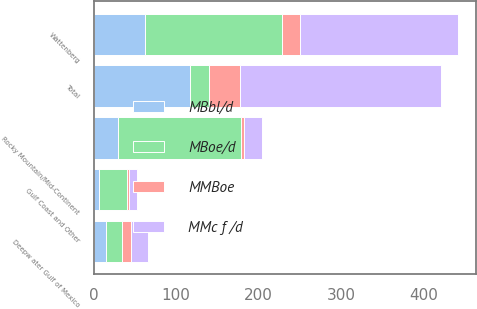<chart> <loc_0><loc_0><loc_500><loc_500><stacked_bar_chart><ecel><fcel>Wattenberg<fcel>Rocky Mountain/Mid-Continent<fcel>Deepw ater Gulf of Mexico<fcel>Gulf Coast and Other<fcel>Total<nl><fcel>MMBoe<fcel>23<fcel>3<fcel>10<fcel>2<fcel>38<nl><fcel>MBoe/d<fcel>166<fcel>149<fcel>20<fcel>34<fcel>23<nl><fcel>MBbl/d<fcel>62<fcel>30<fcel>15<fcel>7<fcel>117<nl><fcel>MMc f /d<fcel>191<fcel>22<fcel>21<fcel>10<fcel>244<nl></chart> 